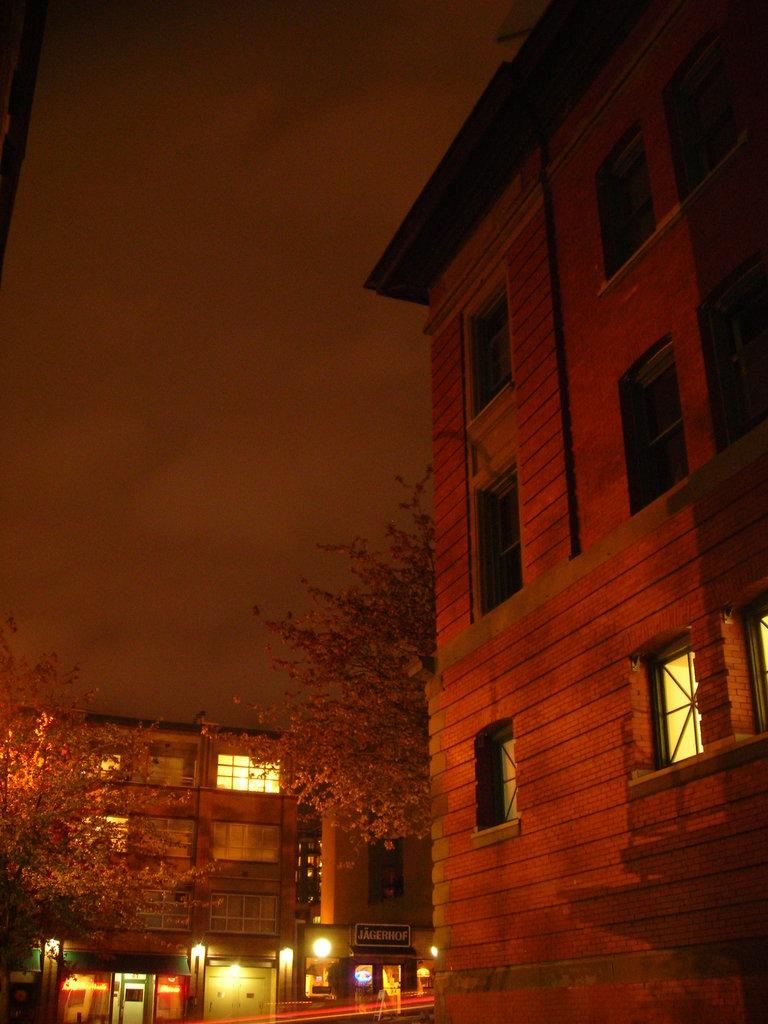Where was the picture taken? The picture was taken outside a building. What can be seen in the background of the image? There are buildings, trees, lights, and a hoarding in the background of the image. What is the condition of the building in the foreground? The building in the foreground has windows. What is the weather like in the image? The sky is cloudy in the image. What type of waste can be seen being disposed of in the image? There is no waste present in the image. What is the boundary between the two buildings in the image? There is no boundary between two buildings visible in the image. 